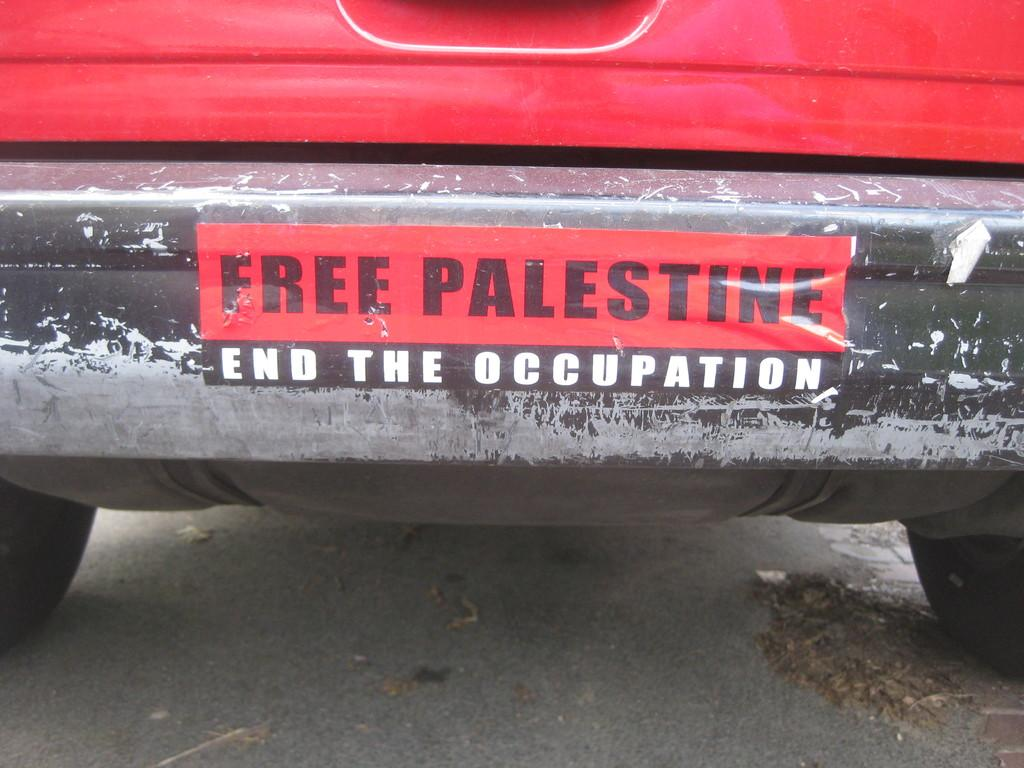What is the main subject of the image? There is a vehicle in the image. Can you describe any additional features of the vehicle? There is a sticker on the vehicle. What type of brick is being used to construct the chair in the image? There is no brick or chair present in the image; it only features a vehicle with a sticker. 